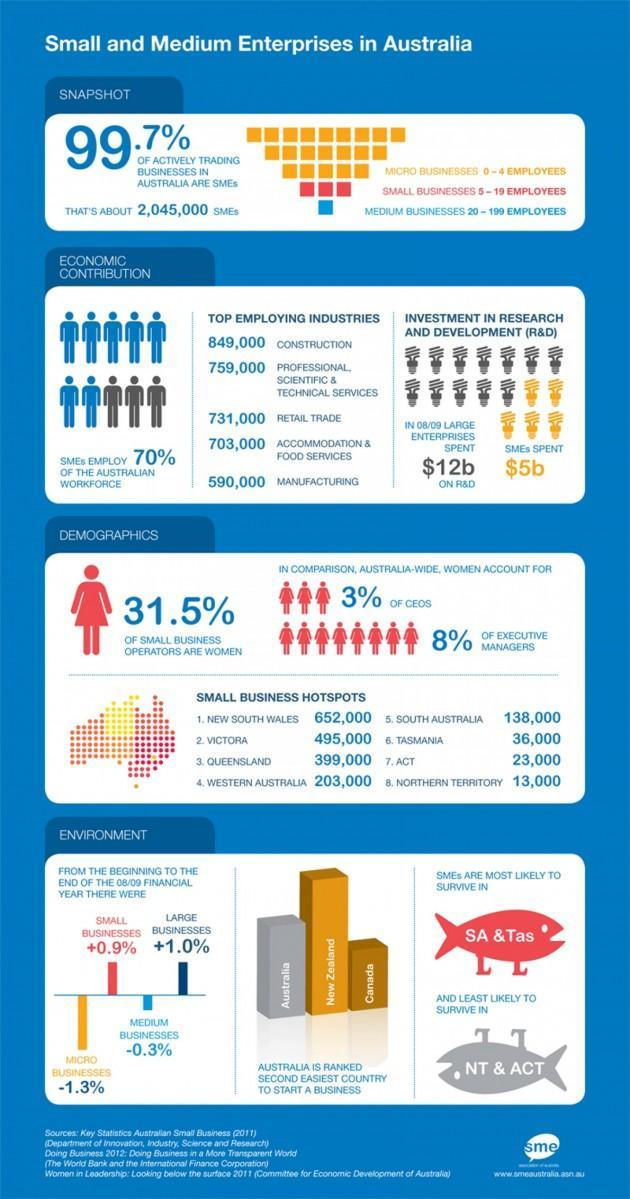How much did SMEs spend on research and development?
Answer the question with a short phrase. $5b Who spent $7b less than the amount spent by large enterprises on R&D? SMEs 